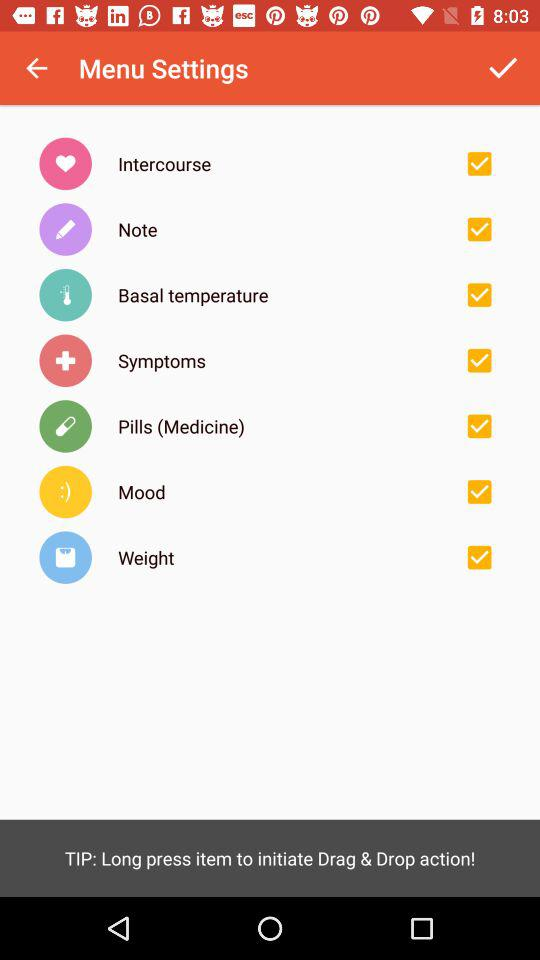What is the status of the mood? The status is "on". 